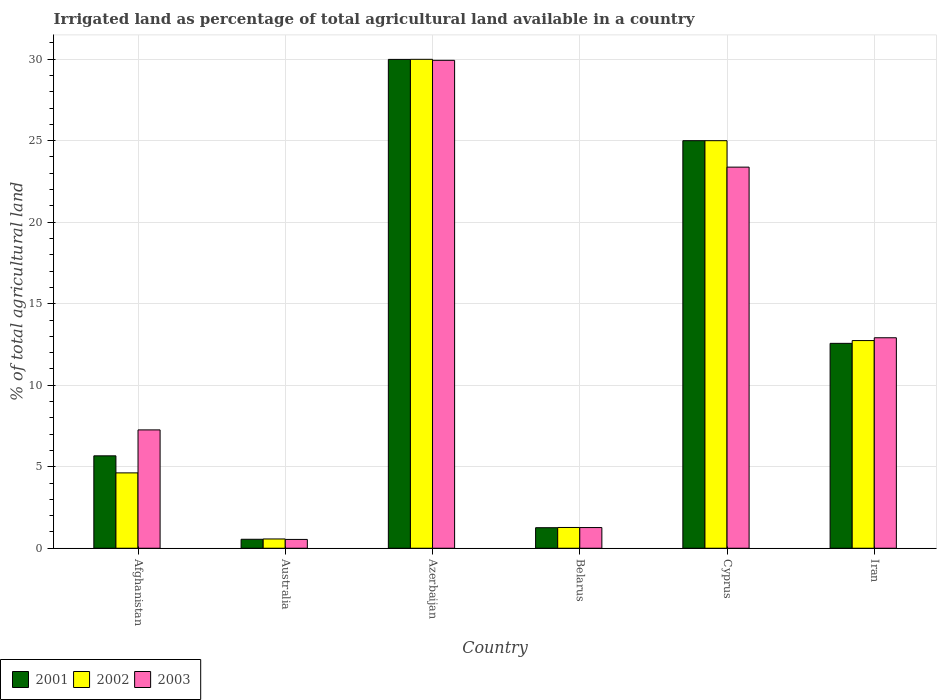Are the number of bars per tick equal to the number of legend labels?
Ensure brevity in your answer.  Yes. How many bars are there on the 6th tick from the left?
Your response must be concise. 3. What is the label of the 6th group of bars from the left?
Provide a short and direct response. Iran. In how many cases, is the number of bars for a given country not equal to the number of legend labels?
Ensure brevity in your answer.  0. What is the percentage of irrigated land in 2002 in Belarus?
Offer a terse response. 1.27. Across all countries, what is the maximum percentage of irrigated land in 2002?
Provide a succinct answer. 29.99. Across all countries, what is the minimum percentage of irrigated land in 2003?
Your answer should be very brief. 0.54. In which country was the percentage of irrigated land in 2001 maximum?
Your answer should be very brief. Azerbaijan. What is the total percentage of irrigated land in 2001 in the graph?
Provide a succinct answer. 75.03. What is the difference between the percentage of irrigated land in 2003 in Australia and that in Belarus?
Ensure brevity in your answer.  -0.73. What is the difference between the percentage of irrigated land in 2002 in Belarus and the percentage of irrigated land in 2001 in Afghanistan?
Your answer should be compact. -4.39. What is the average percentage of irrigated land in 2003 per country?
Give a very brief answer. 12.55. What is the difference between the percentage of irrigated land of/in 2001 and percentage of irrigated land of/in 2003 in Australia?
Make the answer very short. 0.01. In how many countries, is the percentage of irrigated land in 2002 greater than 8 %?
Keep it short and to the point. 3. What is the ratio of the percentage of irrigated land in 2002 in Afghanistan to that in Cyprus?
Ensure brevity in your answer.  0.18. Is the difference between the percentage of irrigated land in 2001 in Afghanistan and Cyprus greater than the difference between the percentage of irrigated land in 2003 in Afghanistan and Cyprus?
Give a very brief answer. No. What is the difference between the highest and the second highest percentage of irrigated land in 2002?
Provide a succinct answer. 12.26. What is the difference between the highest and the lowest percentage of irrigated land in 2003?
Give a very brief answer. 29.39. Is the sum of the percentage of irrigated land in 2001 in Afghanistan and Azerbaijan greater than the maximum percentage of irrigated land in 2003 across all countries?
Your answer should be very brief. Yes. What does the 1st bar from the left in Iran represents?
Your response must be concise. 2001. How many countries are there in the graph?
Your answer should be compact. 6. Are the values on the major ticks of Y-axis written in scientific E-notation?
Offer a very short reply. No. Does the graph contain any zero values?
Offer a terse response. No. How are the legend labels stacked?
Give a very brief answer. Horizontal. What is the title of the graph?
Give a very brief answer. Irrigated land as percentage of total agricultural land available in a country. Does "1993" appear as one of the legend labels in the graph?
Provide a succinct answer. No. What is the label or title of the X-axis?
Provide a short and direct response. Country. What is the label or title of the Y-axis?
Your response must be concise. % of total agricultural land. What is the % of total agricultural land in 2001 in Afghanistan?
Your response must be concise. 5.67. What is the % of total agricultural land of 2002 in Afghanistan?
Give a very brief answer. 4.62. What is the % of total agricultural land of 2003 in Afghanistan?
Offer a terse response. 7.26. What is the % of total agricultural land of 2001 in Australia?
Provide a succinct answer. 0.55. What is the % of total agricultural land in 2002 in Australia?
Make the answer very short. 0.57. What is the % of total agricultural land of 2003 in Australia?
Give a very brief answer. 0.54. What is the % of total agricultural land of 2001 in Azerbaijan?
Provide a short and direct response. 29.99. What is the % of total agricultural land of 2002 in Azerbaijan?
Your answer should be very brief. 29.99. What is the % of total agricultural land of 2003 in Azerbaijan?
Make the answer very short. 29.93. What is the % of total agricultural land of 2001 in Belarus?
Provide a succinct answer. 1.26. What is the % of total agricultural land of 2002 in Belarus?
Your answer should be compact. 1.27. What is the % of total agricultural land in 2003 in Belarus?
Your answer should be very brief. 1.27. What is the % of total agricultural land in 2002 in Cyprus?
Ensure brevity in your answer.  25. What is the % of total agricultural land of 2003 in Cyprus?
Give a very brief answer. 23.38. What is the % of total agricultural land of 2001 in Iran?
Offer a terse response. 12.57. What is the % of total agricultural land in 2002 in Iran?
Your answer should be very brief. 12.74. What is the % of total agricultural land of 2003 in Iran?
Provide a succinct answer. 12.91. Across all countries, what is the maximum % of total agricultural land of 2001?
Your response must be concise. 29.99. Across all countries, what is the maximum % of total agricultural land of 2002?
Give a very brief answer. 29.99. Across all countries, what is the maximum % of total agricultural land in 2003?
Ensure brevity in your answer.  29.93. Across all countries, what is the minimum % of total agricultural land in 2001?
Provide a succinct answer. 0.55. Across all countries, what is the minimum % of total agricultural land in 2002?
Your answer should be very brief. 0.57. Across all countries, what is the minimum % of total agricultural land in 2003?
Ensure brevity in your answer.  0.54. What is the total % of total agricultural land in 2001 in the graph?
Your response must be concise. 75.03. What is the total % of total agricultural land of 2002 in the graph?
Your answer should be very brief. 74.19. What is the total % of total agricultural land of 2003 in the graph?
Ensure brevity in your answer.  75.29. What is the difference between the % of total agricultural land of 2001 in Afghanistan and that in Australia?
Your answer should be compact. 5.12. What is the difference between the % of total agricultural land in 2002 in Afghanistan and that in Australia?
Give a very brief answer. 4.05. What is the difference between the % of total agricultural land in 2003 in Afghanistan and that in Australia?
Provide a short and direct response. 6.72. What is the difference between the % of total agricultural land of 2001 in Afghanistan and that in Azerbaijan?
Offer a very short reply. -24.32. What is the difference between the % of total agricultural land of 2002 in Afghanistan and that in Azerbaijan?
Provide a short and direct response. -25.37. What is the difference between the % of total agricultural land of 2003 in Afghanistan and that in Azerbaijan?
Give a very brief answer. -22.67. What is the difference between the % of total agricultural land in 2001 in Afghanistan and that in Belarus?
Keep it short and to the point. 4.41. What is the difference between the % of total agricultural land in 2002 in Afghanistan and that in Belarus?
Give a very brief answer. 3.35. What is the difference between the % of total agricultural land of 2003 in Afghanistan and that in Belarus?
Offer a terse response. 5.99. What is the difference between the % of total agricultural land of 2001 in Afghanistan and that in Cyprus?
Offer a very short reply. -19.33. What is the difference between the % of total agricultural land in 2002 in Afghanistan and that in Cyprus?
Your answer should be very brief. -20.38. What is the difference between the % of total agricultural land in 2003 in Afghanistan and that in Cyprus?
Your answer should be compact. -16.12. What is the difference between the % of total agricultural land in 2001 in Afghanistan and that in Iran?
Give a very brief answer. -6.9. What is the difference between the % of total agricultural land in 2002 in Afghanistan and that in Iran?
Offer a terse response. -8.12. What is the difference between the % of total agricultural land of 2003 in Afghanistan and that in Iran?
Your answer should be compact. -5.65. What is the difference between the % of total agricultural land in 2001 in Australia and that in Azerbaijan?
Offer a very short reply. -29.44. What is the difference between the % of total agricultural land in 2002 in Australia and that in Azerbaijan?
Give a very brief answer. -29.42. What is the difference between the % of total agricultural land of 2003 in Australia and that in Azerbaijan?
Provide a short and direct response. -29.39. What is the difference between the % of total agricultural land of 2001 in Australia and that in Belarus?
Make the answer very short. -0.71. What is the difference between the % of total agricultural land in 2002 in Australia and that in Belarus?
Make the answer very short. -0.7. What is the difference between the % of total agricultural land of 2003 in Australia and that in Belarus?
Give a very brief answer. -0.73. What is the difference between the % of total agricultural land in 2001 in Australia and that in Cyprus?
Your answer should be compact. -24.45. What is the difference between the % of total agricultural land in 2002 in Australia and that in Cyprus?
Give a very brief answer. -24.43. What is the difference between the % of total agricultural land of 2003 in Australia and that in Cyprus?
Provide a short and direct response. -22.84. What is the difference between the % of total agricultural land in 2001 in Australia and that in Iran?
Your answer should be compact. -12.02. What is the difference between the % of total agricultural land of 2002 in Australia and that in Iran?
Keep it short and to the point. -12.17. What is the difference between the % of total agricultural land in 2003 in Australia and that in Iran?
Offer a terse response. -12.37. What is the difference between the % of total agricultural land in 2001 in Azerbaijan and that in Belarus?
Provide a succinct answer. 28.73. What is the difference between the % of total agricultural land in 2002 in Azerbaijan and that in Belarus?
Provide a succinct answer. 28.72. What is the difference between the % of total agricultural land in 2003 in Azerbaijan and that in Belarus?
Ensure brevity in your answer.  28.66. What is the difference between the % of total agricultural land of 2001 in Azerbaijan and that in Cyprus?
Make the answer very short. 4.99. What is the difference between the % of total agricultural land of 2002 in Azerbaijan and that in Cyprus?
Your answer should be very brief. 4.99. What is the difference between the % of total agricultural land in 2003 in Azerbaijan and that in Cyprus?
Keep it short and to the point. 6.55. What is the difference between the % of total agricultural land in 2001 in Azerbaijan and that in Iran?
Make the answer very short. 17.42. What is the difference between the % of total agricultural land in 2002 in Azerbaijan and that in Iran?
Offer a terse response. 17.25. What is the difference between the % of total agricultural land in 2003 in Azerbaijan and that in Iran?
Keep it short and to the point. 17.02. What is the difference between the % of total agricultural land in 2001 in Belarus and that in Cyprus?
Your answer should be very brief. -23.74. What is the difference between the % of total agricultural land of 2002 in Belarus and that in Cyprus?
Give a very brief answer. -23.73. What is the difference between the % of total agricultural land of 2003 in Belarus and that in Cyprus?
Keep it short and to the point. -22.11. What is the difference between the % of total agricultural land of 2001 in Belarus and that in Iran?
Your answer should be compact. -11.31. What is the difference between the % of total agricultural land of 2002 in Belarus and that in Iran?
Give a very brief answer. -11.46. What is the difference between the % of total agricultural land of 2003 in Belarus and that in Iran?
Ensure brevity in your answer.  -11.64. What is the difference between the % of total agricultural land in 2001 in Cyprus and that in Iran?
Your answer should be very brief. 12.43. What is the difference between the % of total agricultural land of 2002 in Cyprus and that in Iran?
Ensure brevity in your answer.  12.26. What is the difference between the % of total agricultural land of 2003 in Cyprus and that in Iran?
Provide a succinct answer. 10.47. What is the difference between the % of total agricultural land of 2001 in Afghanistan and the % of total agricultural land of 2002 in Australia?
Your answer should be compact. 5.1. What is the difference between the % of total agricultural land of 2001 in Afghanistan and the % of total agricultural land of 2003 in Australia?
Make the answer very short. 5.13. What is the difference between the % of total agricultural land of 2002 in Afghanistan and the % of total agricultural land of 2003 in Australia?
Your answer should be compact. 4.08. What is the difference between the % of total agricultural land in 2001 in Afghanistan and the % of total agricultural land in 2002 in Azerbaijan?
Provide a succinct answer. -24.32. What is the difference between the % of total agricultural land in 2001 in Afghanistan and the % of total agricultural land in 2003 in Azerbaijan?
Your answer should be compact. -24.26. What is the difference between the % of total agricultural land of 2002 in Afghanistan and the % of total agricultural land of 2003 in Azerbaijan?
Keep it short and to the point. -25.31. What is the difference between the % of total agricultural land of 2001 in Afghanistan and the % of total agricultural land of 2002 in Belarus?
Your response must be concise. 4.39. What is the difference between the % of total agricultural land in 2001 in Afghanistan and the % of total agricultural land in 2003 in Belarus?
Your response must be concise. 4.4. What is the difference between the % of total agricultural land of 2002 in Afghanistan and the % of total agricultural land of 2003 in Belarus?
Keep it short and to the point. 3.35. What is the difference between the % of total agricultural land in 2001 in Afghanistan and the % of total agricultural land in 2002 in Cyprus?
Your answer should be compact. -19.33. What is the difference between the % of total agricultural land in 2001 in Afghanistan and the % of total agricultural land in 2003 in Cyprus?
Your response must be concise. -17.71. What is the difference between the % of total agricultural land in 2002 in Afghanistan and the % of total agricultural land in 2003 in Cyprus?
Make the answer very short. -18.75. What is the difference between the % of total agricultural land in 2001 in Afghanistan and the % of total agricultural land in 2002 in Iran?
Offer a terse response. -7.07. What is the difference between the % of total agricultural land of 2001 in Afghanistan and the % of total agricultural land of 2003 in Iran?
Keep it short and to the point. -7.24. What is the difference between the % of total agricultural land in 2002 in Afghanistan and the % of total agricultural land in 2003 in Iran?
Make the answer very short. -8.29. What is the difference between the % of total agricultural land of 2001 in Australia and the % of total agricultural land of 2002 in Azerbaijan?
Your answer should be compact. -29.44. What is the difference between the % of total agricultural land in 2001 in Australia and the % of total agricultural land in 2003 in Azerbaijan?
Make the answer very short. -29.38. What is the difference between the % of total agricultural land of 2002 in Australia and the % of total agricultural land of 2003 in Azerbaijan?
Keep it short and to the point. -29.36. What is the difference between the % of total agricultural land in 2001 in Australia and the % of total agricultural land in 2002 in Belarus?
Provide a short and direct response. -0.72. What is the difference between the % of total agricultural land in 2001 in Australia and the % of total agricultural land in 2003 in Belarus?
Your answer should be compact. -0.72. What is the difference between the % of total agricultural land in 2002 in Australia and the % of total agricultural land in 2003 in Belarus?
Your response must be concise. -0.7. What is the difference between the % of total agricultural land in 2001 in Australia and the % of total agricultural land in 2002 in Cyprus?
Provide a short and direct response. -24.45. What is the difference between the % of total agricultural land in 2001 in Australia and the % of total agricultural land in 2003 in Cyprus?
Ensure brevity in your answer.  -22.83. What is the difference between the % of total agricultural land of 2002 in Australia and the % of total agricultural land of 2003 in Cyprus?
Give a very brief answer. -22.81. What is the difference between the % of total agricultural land in 2001 in Australia and the % of total agricultural land in 2002 in Iran?
Your answer should be very brief. -12.19. What is the difference between the % of total agricultural land of 2001 in Australia and the % of total agricultural land of 2003 in Iran?
Make the answer very short. -12.36. What is the difference between the % of total agricultural land in 2002 in Australia and the % of total agricultural land in 2003 in Iran?
Your answer should be very brief. -12.34. What is the difference between the % of total agricultural land of 2001 in Azerbaijan and the % of total agricultural land of 2002 in Belarus?
Ensure brevity in your answer.  28.71. What is the difference between the % of total agricultural land in 2001 in Azerbaijan and the % of total agricultural land in 2003 in Belarus?
Offer a terse response. 28.72. What is the difference between the % of total agricultural land in 2002 in Azerbaijan and the % of total agricultural land in 2003 in Belarus?
Give a very brief answer. 28.72. What is the difference between the % of total agricultural land of 2001 in Azerbaijan and the % of total agricultural land of 2002 in Cyprus?
Give a very brief answer. 4.99. What is the difference between the % of total agricultural land in 2001 in Azerbaijan and the % of total agricultural land in 2003 in Cyprus?
Provide a succinct answer. 6.61. What is the difference between the % of total agricultural land in 2002 in Azerbaijan and the % of total agricultural land in 2003 in Cyprus?
Give a very brief answer. 6.61. What is the difference between the % of total agricultural land of 2001 in Azerbaijan and the % of total agricultural land of 2002 in Iran?
Your response must be concise. 17.25. What is the difference between the % of total agricultural land of 2001 in Azerbaijan and the % of total agricultural land of 2003 in Iran?
Make the answer very short. 17.08. What is the difference between the % of total agricultural land of 2002 in Azerbaijan and the % of total agricultural land of 2003 in Iran?
Keep it short and to the point. 17.08. What is the difference between the % of total agricultural land in 2001 in Belarus and the % of total agricultural land in 2002 in Cyprus?
Your response must be concise. -23.74. What is the difference between the % of total agricultural land in 2001 in Belarus and the % of total agricultural land in 2003 in Cyprus?
Give a very brief answer. -22.12. What is the difference between the % of total agricultural land of 2002 in Belarus and the % of total agricultural land of 2003 in Cyprus?
Ensure brevity in your answer.  -22.1. What is the difference between the % of total agricultural land of 2001 in Belarus and the % of total agricultural land of 2002 in Iran?
Ensure brevity in your answer.  -11.48. What is the difference between the % of total agricultural land of 2001 in Belarus and the % of total agricultural land of 2003 in Iran?
Your answer should be compact. -11.65. What is the difference between the % of total agricultural land of 2002 in Belarus and the % of total agricultural land of 2003 in Iran?
Make the answer very short. -11.64. What is the difference between the % of total agricultural land in 2001 in Cyprus and the % of total agricultural land in 2002 in Iran?
Ensure brevity in your answer.  12.26. What is the difference between the % of total agricultural land in 2001 in Cyprus and the % of total agricultural land in 2003 in Iran?
Provide a short and direct response. 12.09. What is the difference between the % of total agricultural land in 2002 in Cyprus and the % of total agricultural land in 2003 in Iran?
Give a very brief answer. 12.09. What is the average % of total agricultural land in 2001 per country?
Provide a succinct answer. 12.51. What is the average % of total agricultural land of 2002 per country?
Offer a very short reply. 12.37. What is the average % of total agricultural land in 2003 per country?
Ensure brevity in your answer.  12.55. What is the difference between the % of total agricultural land of 2001 and % of total agricultural land of 2002 in Afghanistan?
Your answer should be compact. 1.05. What is the difference between the % of total agricultural land of 2001 and % of total agricultural land of 2003 in Afghanistan?
Offer a terse response. -1.59. What is the difference between the % of total agricultural land of 2002 and % of total agricultural land of 2003 in Afghanistan?
Your answer should be compact. -2.64. What is the difference between the % of total agricultural land of 2001 and % of total agricultural land of 2002 in Australia?
Ensure brevity in your answer.  -0.02. What is the difference between the % of total agricultural land in 2001 and % of total agricultural land in 2003 in Australia?
Your answer should be compact. 0.01. What is the difference between the % of total agricultural land in 2002 and % of total agricultural land in 2003 in Australia?
Your answer should be very brief. 0.03. What is the difference between the % of total agricultural land of 2001 and % of total agricultural land of 2002 in Azerbaijan?
Ensure brevity in your answer.  -0. What is the difference between the % of total agricultural land in 2001 and % of total agricultural land in 2003 in Azerbaijan?
Your answer should be very brief. 0.06. What is the difference between the % of total agricultural land of 2002 and % of total agricultural land of 2003 in Azerbaijan?
Your response must be concise. 0.06. What is the difference between the % of total agricultural land of 2001 and % of total agricultural land of 2002 in Belarus?
Provide a short and direct response. -0.01. What is the difference between the % of total agricultural land in 2001 and % of total agricultural land in 2003 in Belarus?
Keep it short and to the point. -0.01. What is the difference between the % of total agricultural land of 2002 and % of total agricultural land of 2003 in Belarus?
Ensure brevity in your answer.  0.01. What is the difference between the % of total agricultural land in 2001 and % of total agricultural land in 2003 in Cyprus?
Provide a short and direct response. 1.62. What is the difference between the % of total agricultural land of 2002 and % of total agricultural land of 2003 in Cyprus?
Your answer should be compact. 1.62. What is the difference between the % of total agricultural land in 2001 and % of total agricultural land in 2002 in Iran?
Your response must be concise. -0.17. What is the difference between the % of total agricultural land in 2001 and % of total agricultural land in 2003 in Iran?
Ensure brevity in your answer.  -0.34. What is the difference between the % of total agricultural land of 2002 and % of total agricultural land of 2003 in Iran?
Your response must be concise. -0.17. What is the ratio of the % of total agricultural land in 2001 in Afghanistan to that in Australia?
Make the answer very short. 10.31. What is the ratio of the % of total agricultural land in 2002 in Afghanistan to that in Australia?
Provide a short and direct response. 8.12. What is the ratio of the % of total agricultural land in 2003 in Afghanistan to that in Australia?
Ensure brevity in your answer.  13.42. What is the ratio of the % of total agricultural land of 2001 in Afghanistan to that in Azerbaijan?
Offer a terse response. 0.19. What is the ratio of the % of total agricultural land in 2002 in Afghanistan to that in Azerbaijan?
Offer a very short reply. 0.15. What is the ratio of the % of total agricultural land of 2003 in Afghanistan to that in Azerbaijan?
Your answer should be very brief. 0.24. What is the ratio of the % of total agricultural land of 2001 in Afghanistan to that in Belarus?
Offer a terse response. 4.5. What is the ratio of the % of total agricultural land of 2002 in Afghanistan to that in Belarus?
Your response must be concise. 3.63. What is the ratio of the % of total agricultural land of 2003 in Afghanistan to that in Belarus?
Make the answer very short. 5.72. What is the ratio of the % of total agricultural land of 2001 in Afghanistan to that in Cyprus?
Keep it short and to the point. 0.23. What is the ratio of the % of total agricultural land of 2002 in Afghanistan to that in Cyprus?
Provide a short and direct response. 0.18. What is the ratio of the % of total agricultural land of 2003 in Afghanistan to that in Cyprus?
Your response must be concise. 0.31. What is the ratio of the % of total agricultural land in 2001 in Afghanistan to that in Iran?
Offer a terse response. 0.45. What is the ratio of the % of total agricultural land of 2002 in Afghanistan to that in Iran?
Keep it short and to the point. 0.36. What is the ratio of the % of total agricultural land of 2003 in Afghanistan to that in Iran?
Provide a short and direct response. 0.56. What is the ratio of the % of total agricultural land in 2001 in Australia to that in Azerbaijan?
Your answer should be compact. 0.02. What is the ratio of the % of total agricultural land of 2002 in Australia to that in Azerbaijan?
Provide a short and direct response. 0.02. What is the ratio of the % of total agricultural land in 2003 in Australia to that in Azerbaijan?
Your answer should be compact. 0.02. What is the ratio of the % of total agricultural land in 2001 in Australia to that in Belarus?
Your answer should be very brief. 0.44. What is the ratio of the % of total agricultural land of 2002 in Australia to that in Belarus?
Ensure brevity in your answer.  0.45. What is the ratio of the % of total agricultural land of 2003 in Australia to that in Belarus?
Offer a very short reply. 0.43. What is the ratio of the % of total agricultural land in 2001 in Australia to that in Cyprus?
Give a very brief answer. 0.02. What is the ratio of the % of total agricultural land of 2002 in Australia to that in Cyprus?
Give a very brief answer. 0.02. What is the ratio of the % of total agricultural land in 2003 in Australia to that in Cyprus?
Ensure brevity in your answer.  0.02. What is the ratio of the % of total agricultural land of 2001 in Australia to that in Iran?
Keep it short and to the point. 0.04. What is the ratio of the % of total agricultural land of 2002 in Australia to that in Iran?
Your response must be concise. 0.04. What is the ratio of the % of total agricultural land in 2003 in Australia to that in Iran?
Your answer should be very brief. 0.04. What is the ratio of the % of total agricultural land in 2001 in Azerbaijan to that in Belarus?
Give a very brief answer. 23.8. What is the ratio of the % of total agricultural land of 2002 in Azerbaijan to that in Belarus?
Make the answer very short. 23.54. What is the ratio of the % of total agricultural land of 2003 in Azerbaijan to that in Belarus?
Your response must be concise. 23.59. What is the ratio of the % of total agricultural land in 2001 in Azerbaijan to that in Cyprus?
Your answer should be very brief. 1.2. What is the ratio of the % of total agricultural land of 2002 in Azerbaijan to that in Cyprus?
Provide a succinct answer. 1.2. What is the ratio of the % of total agricultural land of 2003 in Azerbaijan to that in Cyprus?
Your answer should be compact. 1.28. What is the ratio of the % of total agricultural land in 2001 in Azerbaijan to that in Iran?
Give a very brief answer. 2.39. What is the ratio of the % of total agricultural land of 2002 in Azerbaijan to that in Iran?
Your response must be concise. 2.35. What is the ratio of the % of total agricultural land of 2003 in Azerbaijan to that in Iran?
Your answer should be compact. 2.32. What is the ratio of the % of total agricultural land in 2001 in Belarus to that in Cyprus?
Your answer should be compact. 0.05. What is the ratio of the % of total agricultural land in 2002 in Belarus to that in Cyprus?
Keep it short and to the point. 0.05. What is the ratio of the % of total agricultural land in 2003 in Belarus to that in Cyprus?
Give a very brief answer. 0.05. What is the ratio of the % of total agricultural land of 2001 in Belarus to that in Iran?
Ensure brevity in your answer.  0.1. What is the ratio of the % of total agricultural land of 2002 in Belarus to that in Iran?
Provide a succinct answer. 0.1. What is the ratio of the % of total agricultural land of 2003 in Belarus to that in Iran?
Your response must be concise. 0.1. What is the ratio of the % of total agricultural land of 2001 in Cyprus to that in Iran?
Keep it short and to the point. 1.99. What is the ratio of the % of total agricultural land of 2002 in Cyprus to that in Iran?
Your answer should be very brief. 1.96. What is the ratio of the % of total agricultural land in 2003 in Cyprus to that in Iran?
Give a very brief answer. 1.81. What is the difference between the highest and the second highest % of total agricultural land of 2001?
Your response must be concise. 4.99. What is the difference between the highest and the second highest % of total agricultural land of 2002?
Make the answer very short. 4.99. What is the difference between the highest and the second highest % of total agricultural land of 2003?
Your answer should be compact. 6.55. What is the difference between the highest and the lowest % of total agricultural land in 2001?
Give a very brief answer. 29.44. What is the difference between the highest and the lowest % of total agricultural land of 2002?
Provide a succinct answer. 29.42. What is the difference between the highest and the lowest % of total agricultural land of 2003?
Your answer should be very brief. 29.39. 